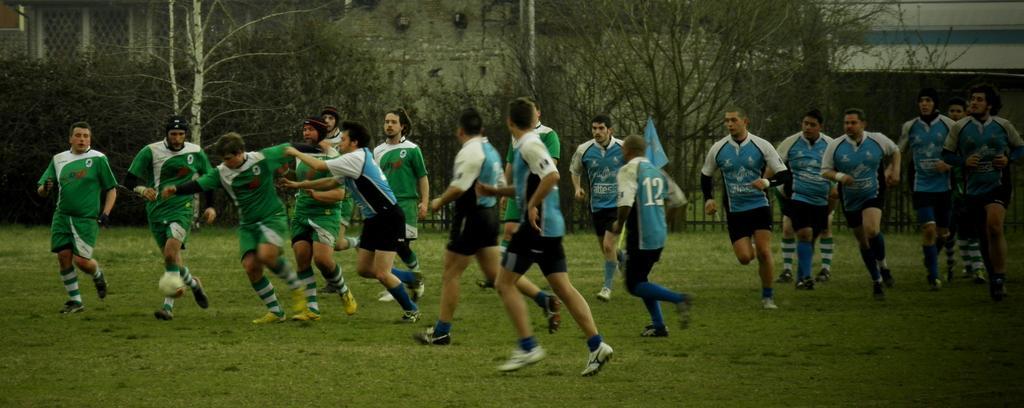How would you summarize this image in a sentence or two? In this image I can see a group of people running and they are wearing blue, white, black and green color dresses. Back I can see few trees, fencing and building. 